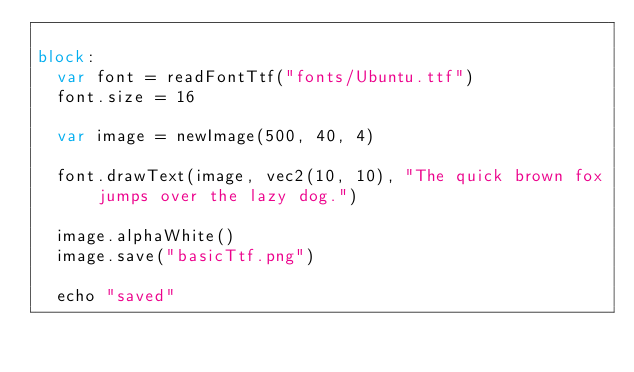Convert code to text. <code><loc_0><loc_0><loc_500><loc_500><_Nim_>
block:
  var font = readFontTtf("fonts/Ubuntu.ttf")
  font.size = 16
    
  var image = newImage(500, 40, 4)

  font.drawText(image, vec2(10, 10), "The quick brown fox jumps over the lazy dog.")

  image.alphaWhite()
  image.save("basicTtf.png")

  echo "saved"</code> 